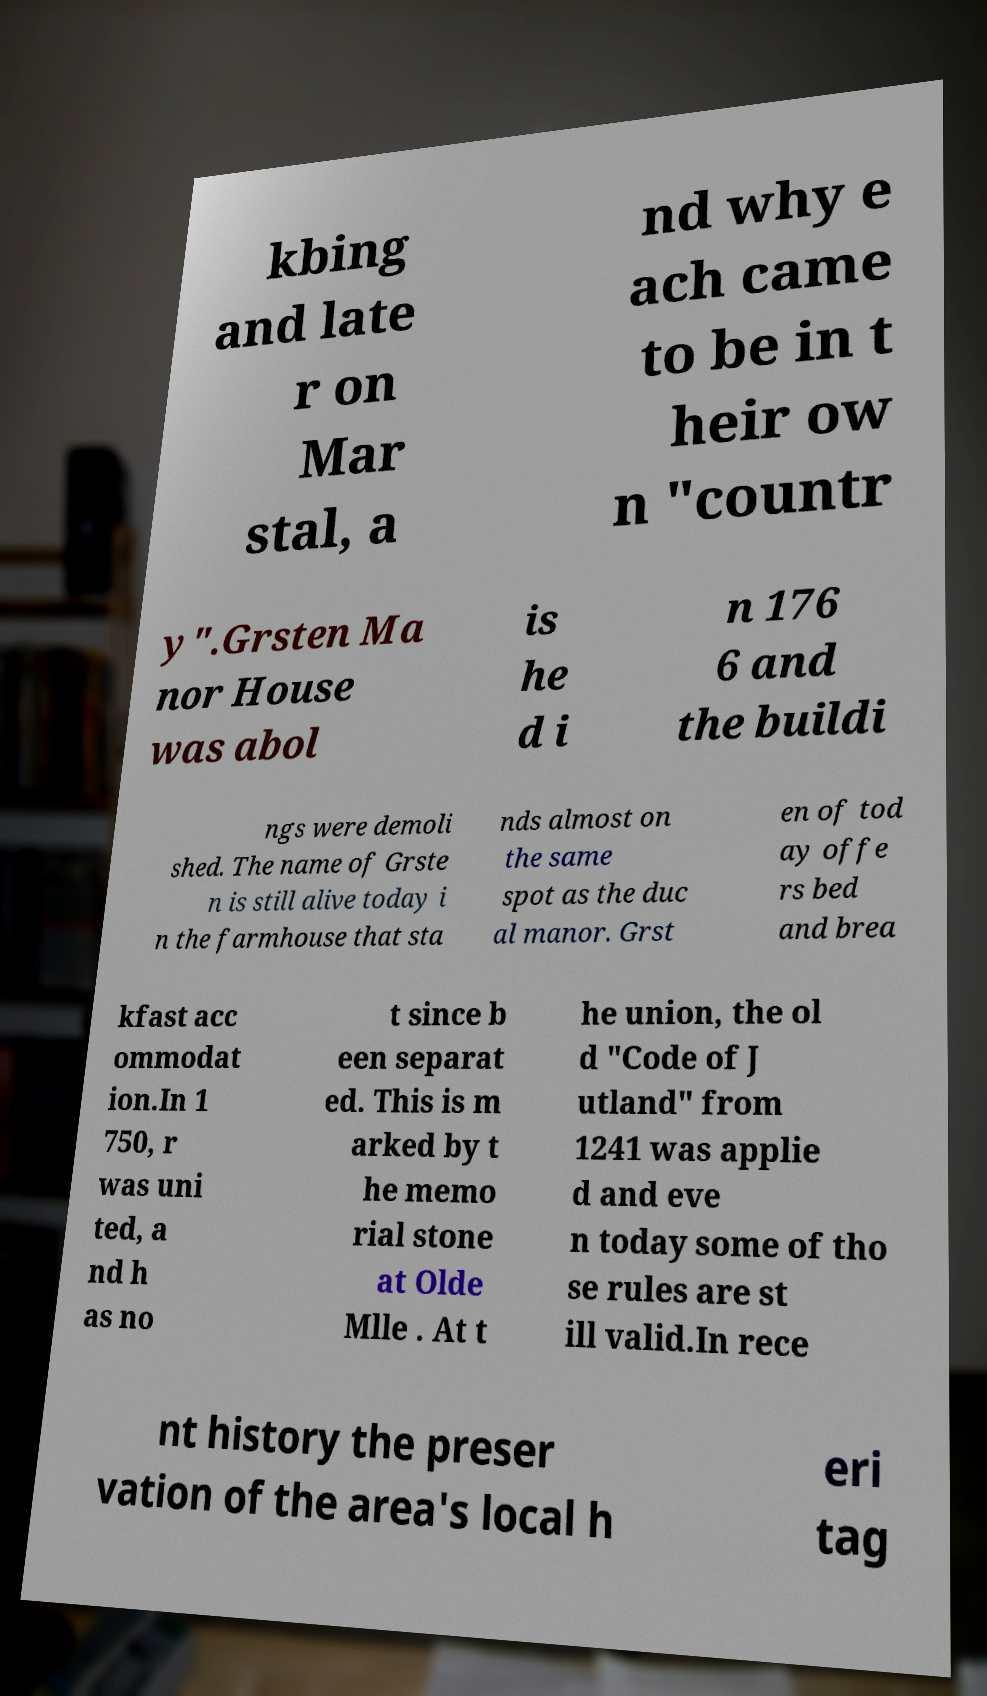I need the written content from this picture converted into text. Can you do that? kbing and late r on Mar stal, a nd why e ach came to be in t heir ow n "countr y".Grsten Ma nor House was abol is he d i n 176 6 and the buildi ngs were demoli shed. The name of Grste n is still alive today i n the farmhouse that sta nds almost on the same spot as the duc al manor. Grst en of tod ay offe rs bed and brea kfast acc ommodat ion.In 1 750, r was uni ted, a nd h as no t since b een separat ed. This is m arked by t he memo rial stone at Olde Mlle . At t he union, the ol d "Code of J utland" from 1241 was applie d and eve n today some of tho se rules are st ill valid.In rece nt history the preser vation of the area's local h eri tag 